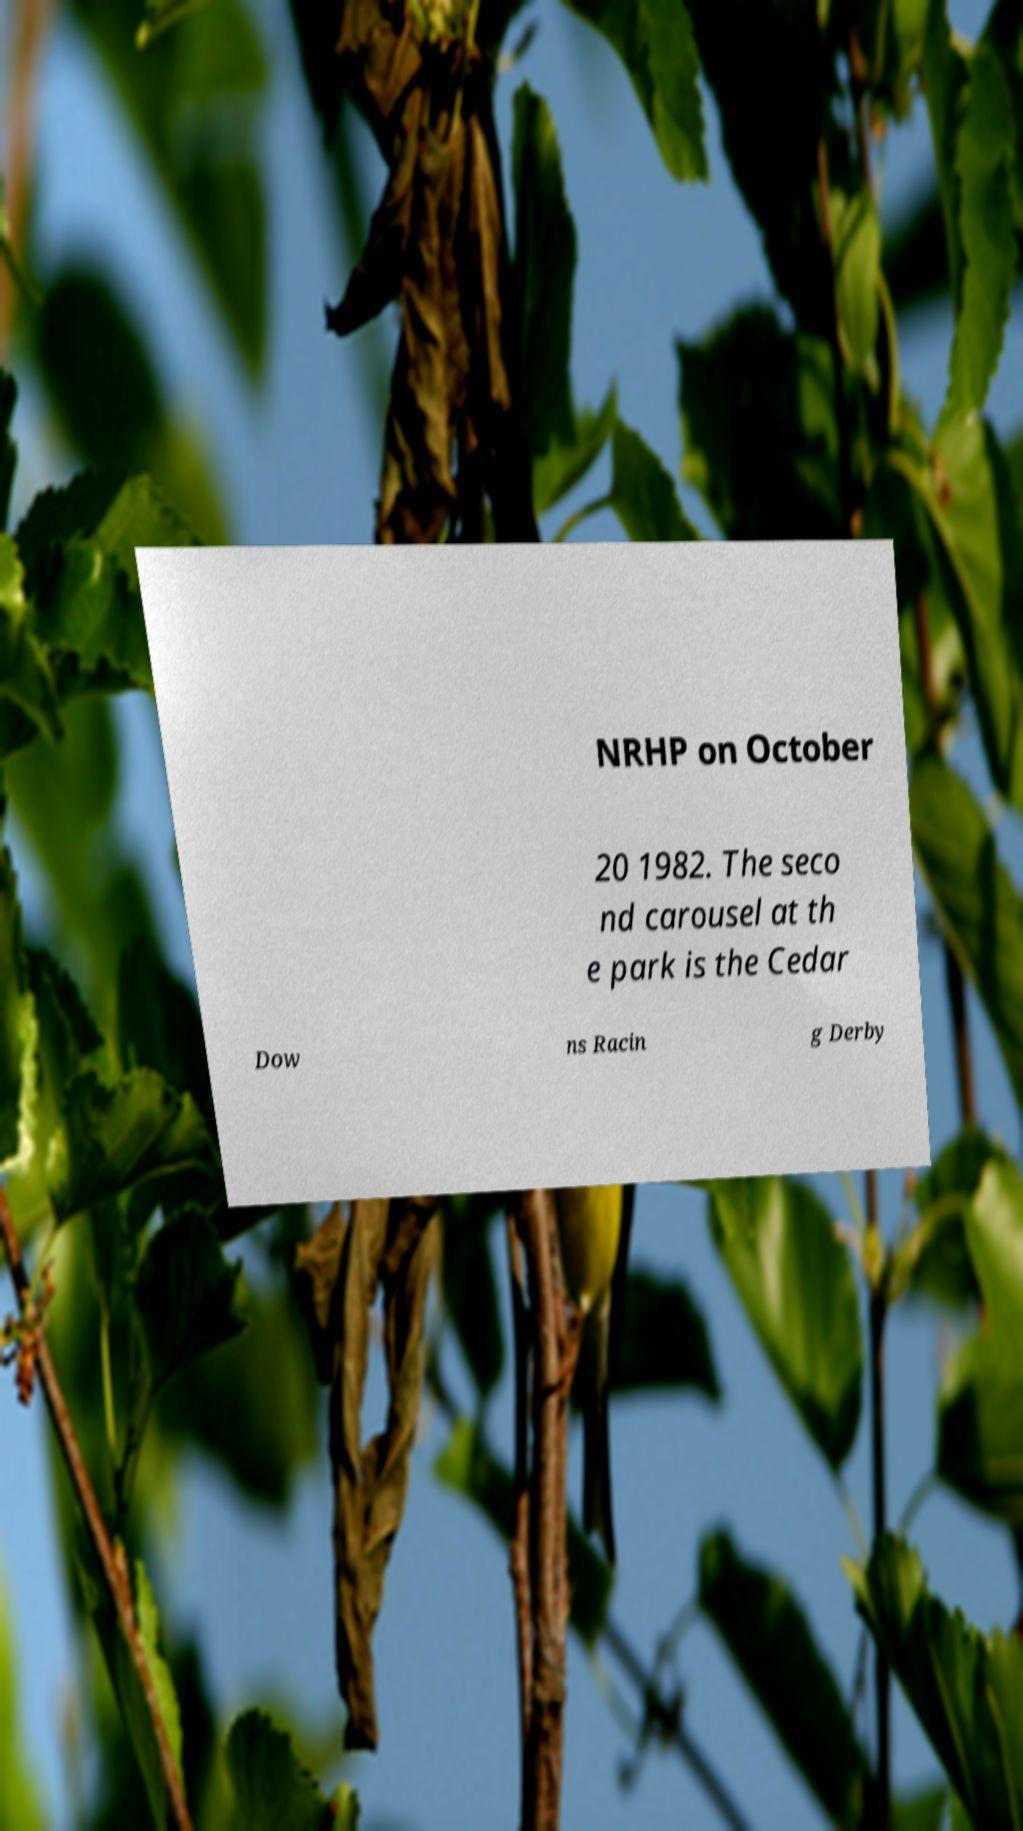Could you extract and type out the text from this image? NRHP on October 20 1982. The seco nd carousel at th e park is the Cedar Dow ns Racin g Derby 